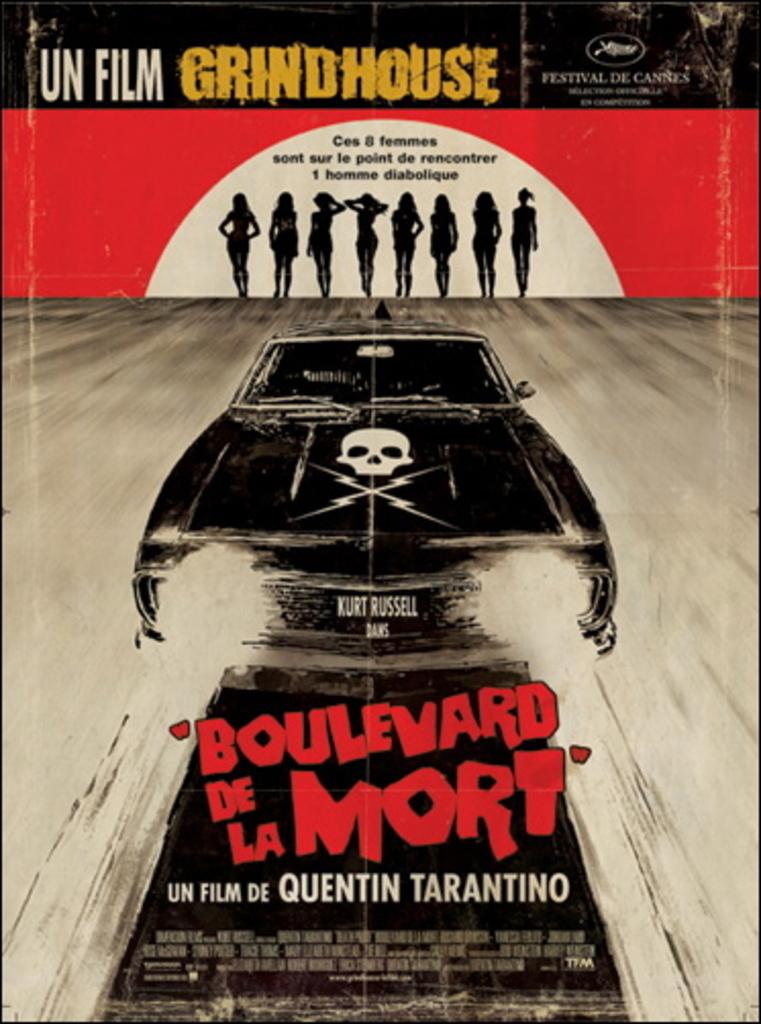Who is the director of this film?
Your answer should be very brief. Quentin tarantino. Is the poster written in english?
Your response must be concise. No. 